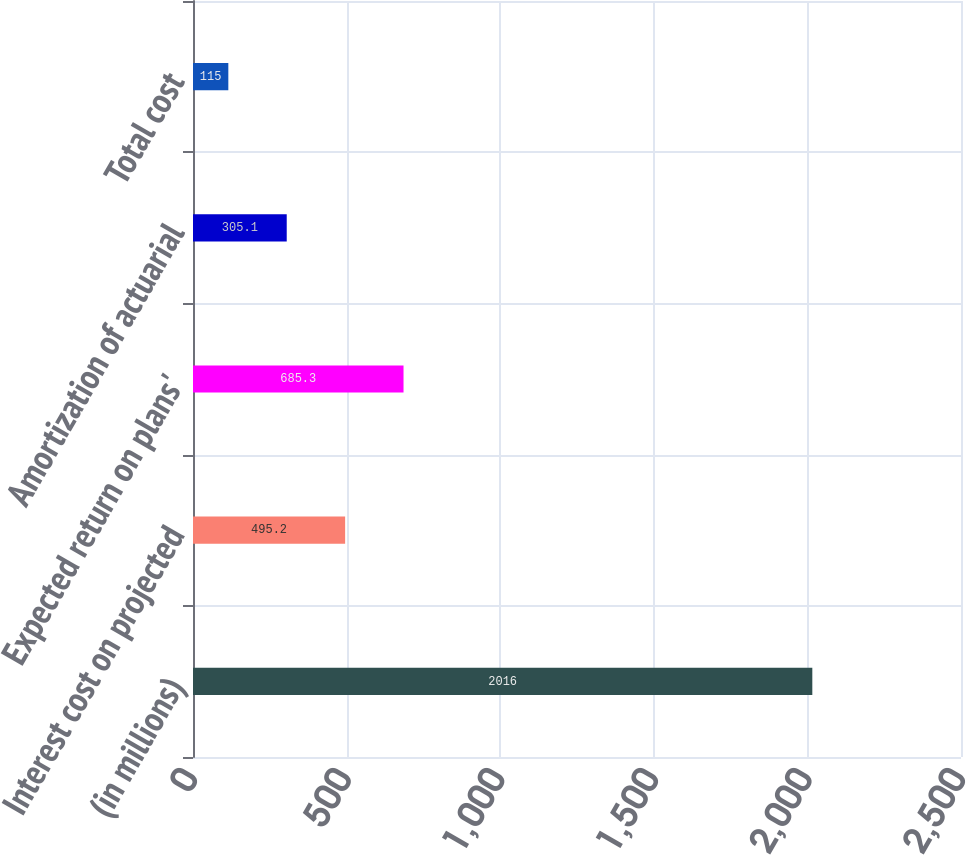Convert chart. <chart><loc_0><loc_0><loc_500><loc_500><bar_chart><fcel>(in millions)<fcel>Interest cost on projected<fcel>Expected return on plans'<fcel>Amortization of actuarial<fcel>Total cost<nl><fcel>2016<fcel>495.2<fcel>685.3<fcel>305.1<fcel>115<nl></chart> 